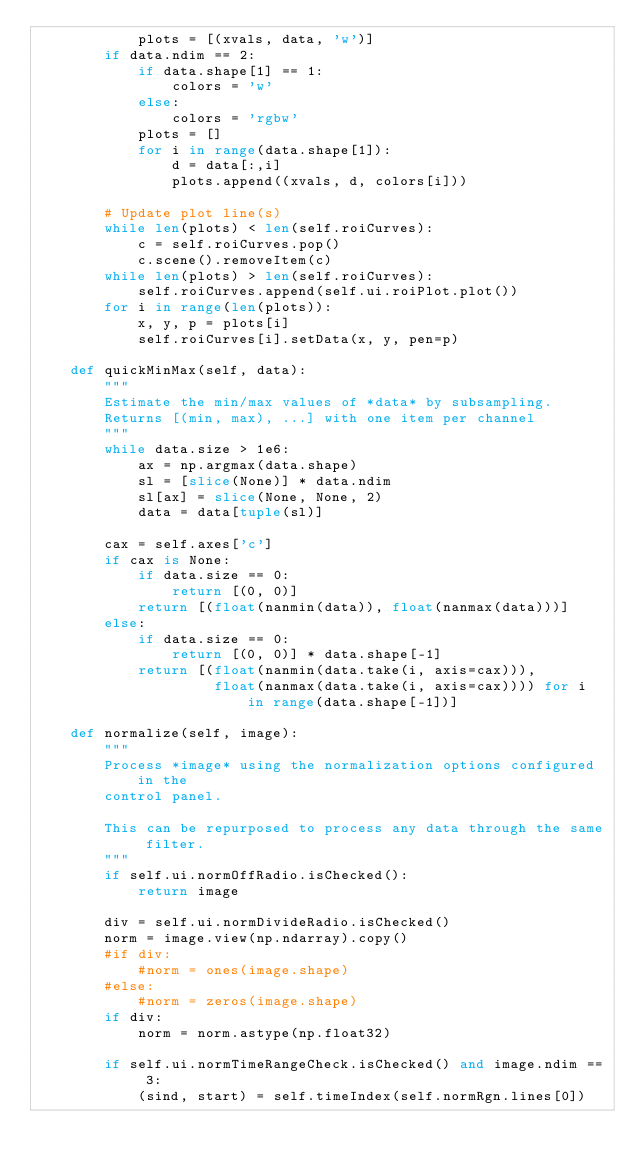Convert code to text. <code><loc_0><loc_0><loc_500><loc_500><_Python_>            plots = [(xvals, data, 'w')]
        if data.ndim == 2:
            if data.shape[1] == 1:
                colors = 'w'
            else:
                colors = 'rgbw'
            plots = []
            for i in range(data.shape[1]):
                d = data[:,i]
                plots.append((xvals, d, colors[i]))

        # Update plot line(s)
        while len(plots) < len(self.roiCurves):
            c = self.roiCurves.pop()
            c.scene().removeItem(c)
        while len(plots) > len(self.roiCurves):
            self.roiCurves.append(self.ui.roiPlot.plot())
        for i in range(len(plots)):
            x, y, p = plots[i]
            self.roiCurves[i].setData(x, y, pen=p)

    def quickMinMax(self, data):
        """
        Estimate the min/max values of *data* by subsampling.
        Returns [(min, max), ...] with one item per channel
        """
        while data.size > 1e6:
            ax = np.argmax(data.shape)
            sl = [slice(None)] * data.ndim
            sl[ax] = slice(None, None, 2)
            data = data[tuple(sl)]
            
        cax = self.axes['c']
        if cax is None:
            if data.size == 0:
                return [(0, 0)]
            return [(float(nanmin(data)), float(nanmax(data)))]
        else:
            if data.size == 0:
                return [(0, 0)] * data.shape[-1]
            return [(float(nanmin(data.take(i, axis=cax))), 
                     float(nanmax(data.take(i, axis=cax)))) for i in range(data.shape[-1])]

    def normalize(self, image):
        """
        Process *image* using the normalization options configured in the
        control panel.
        
        This can be repurposed to process any data through the same filter.
        """
        if self.ui.normOffRadio.isChecked():
            return image
            
        div = self.ui.normDivideRadio.isChecked()
        norm = image.view(np.ndarray).copy()
        #if div:
            #norm = ones(image.shape)
        #else:
            #norm = zeros(image.shape)
        if div:
            norm = norm.astype(np.float32)
            
        if self.ui.normTimeRangeCheck.isChecked() and image.ndim == 3:
            (sind, start) = self.timeIndex(self.normRgn.lines[0])</code> 